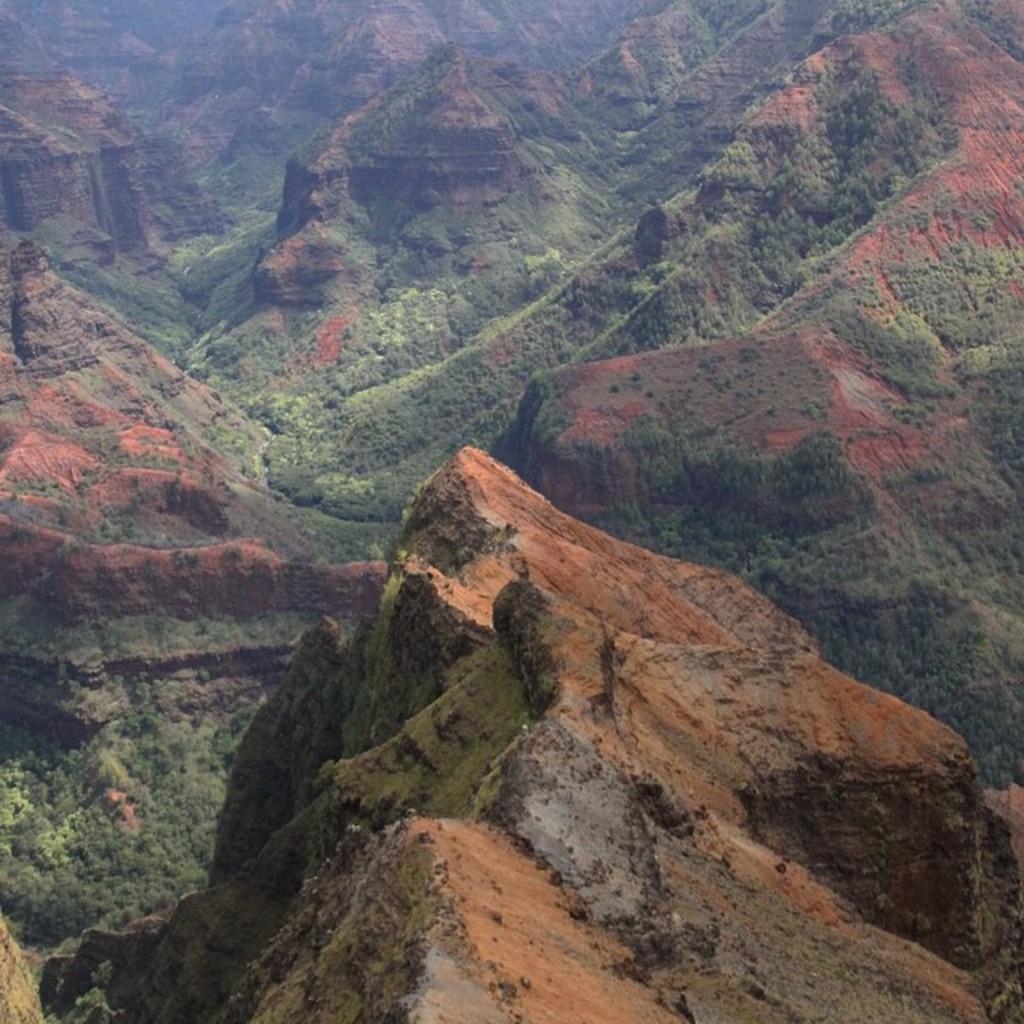In one or two sentences, can you explain what this image depicts? In this image we can see some mountains which are in red and green color. 